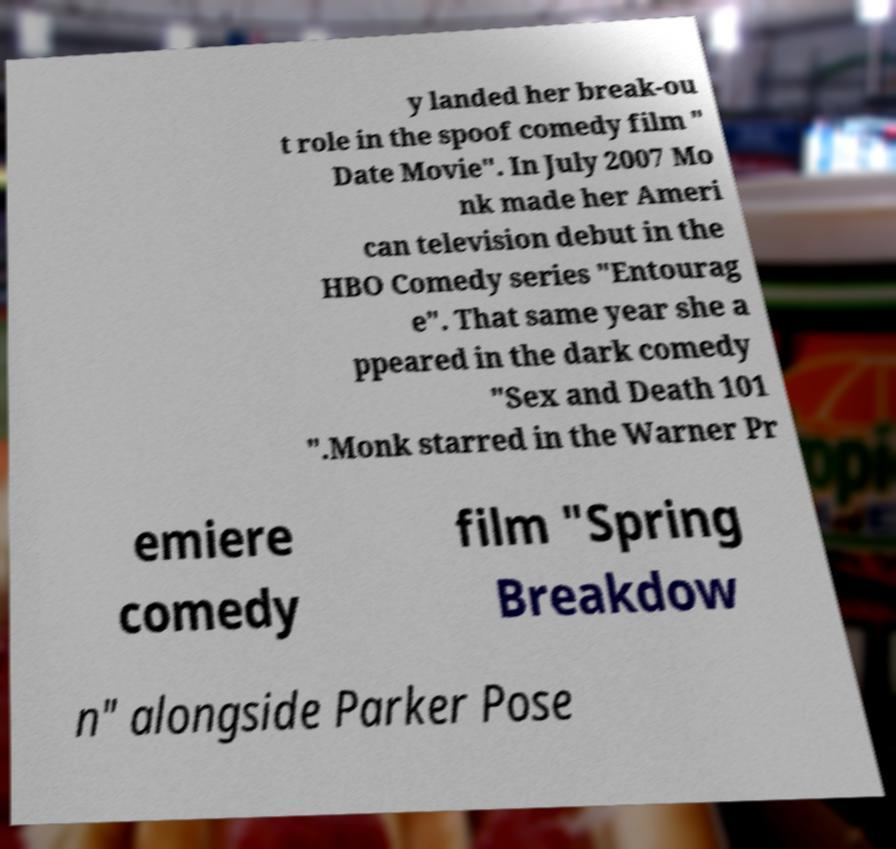Can you accurately transcribe the text from the provided image for me? y landed her break-ou t role in the spoof comedy film " Date Movie". In July 2007 Mo nk made her Ameri can television debut in the HBO Comedy series "Entourag e". That same year she a ppeared in the dark comedy "Sex and Death 101 ".Monk starred in the Warner Pr emiere comedy film "Spring Breakdow n" alongside Parker Pose 